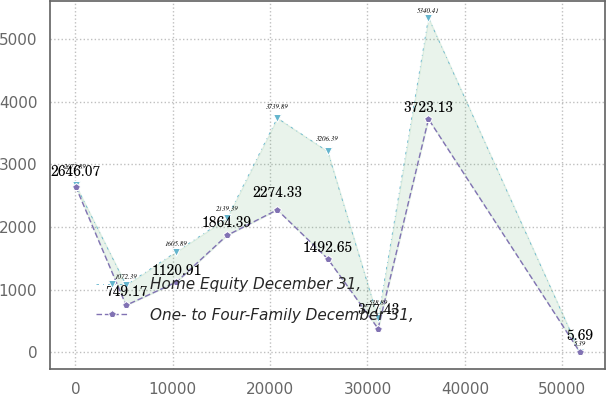Convert chart to OTSL. <chart><loc_0><loc_0><loc_500><loc_500><line_chart><ecel><fcel>Home Equity December 31,<fcel>One- to Four-Family December 31,<nl><fcel>33.66<fcel>2672.89<fcel>2646.07<nl><fcel>5209.39<fcel>1072.39<fcel>749.17<nl><fcel>10385.1<fcel>1605.89<fcel>1120.91<nl><fcel>15560.9<fcel>2139.39<fcel>1864.39<nl><fcel>20736.6<fcel>3739.89<fcel>2274.33<nl><fcel>25912.3<fcel>3206.39<fcel>1492.65<nl><fcel>31088<fcel>538.89<fcel>377.43<nl><fcel>36263.8<fcel>5340.41<fcel>3723.13<nl><fcel>51790.9<fcel>5.39<fcel>5.69<nl></chart> 